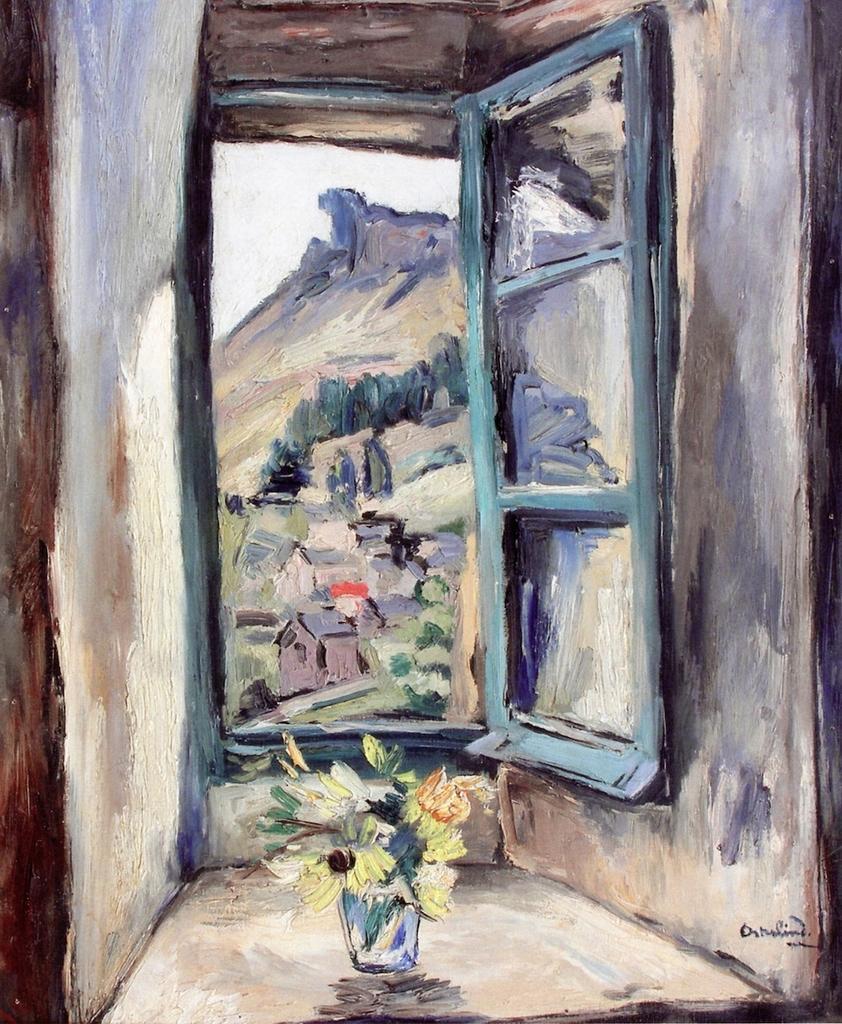Could you give a brief overview of what you see in this image? This is a painting in this picture in the foreground there is an inner view of the house, and there is a window and one flower pot and plant. In the background there are some mountains, trees and houses. 